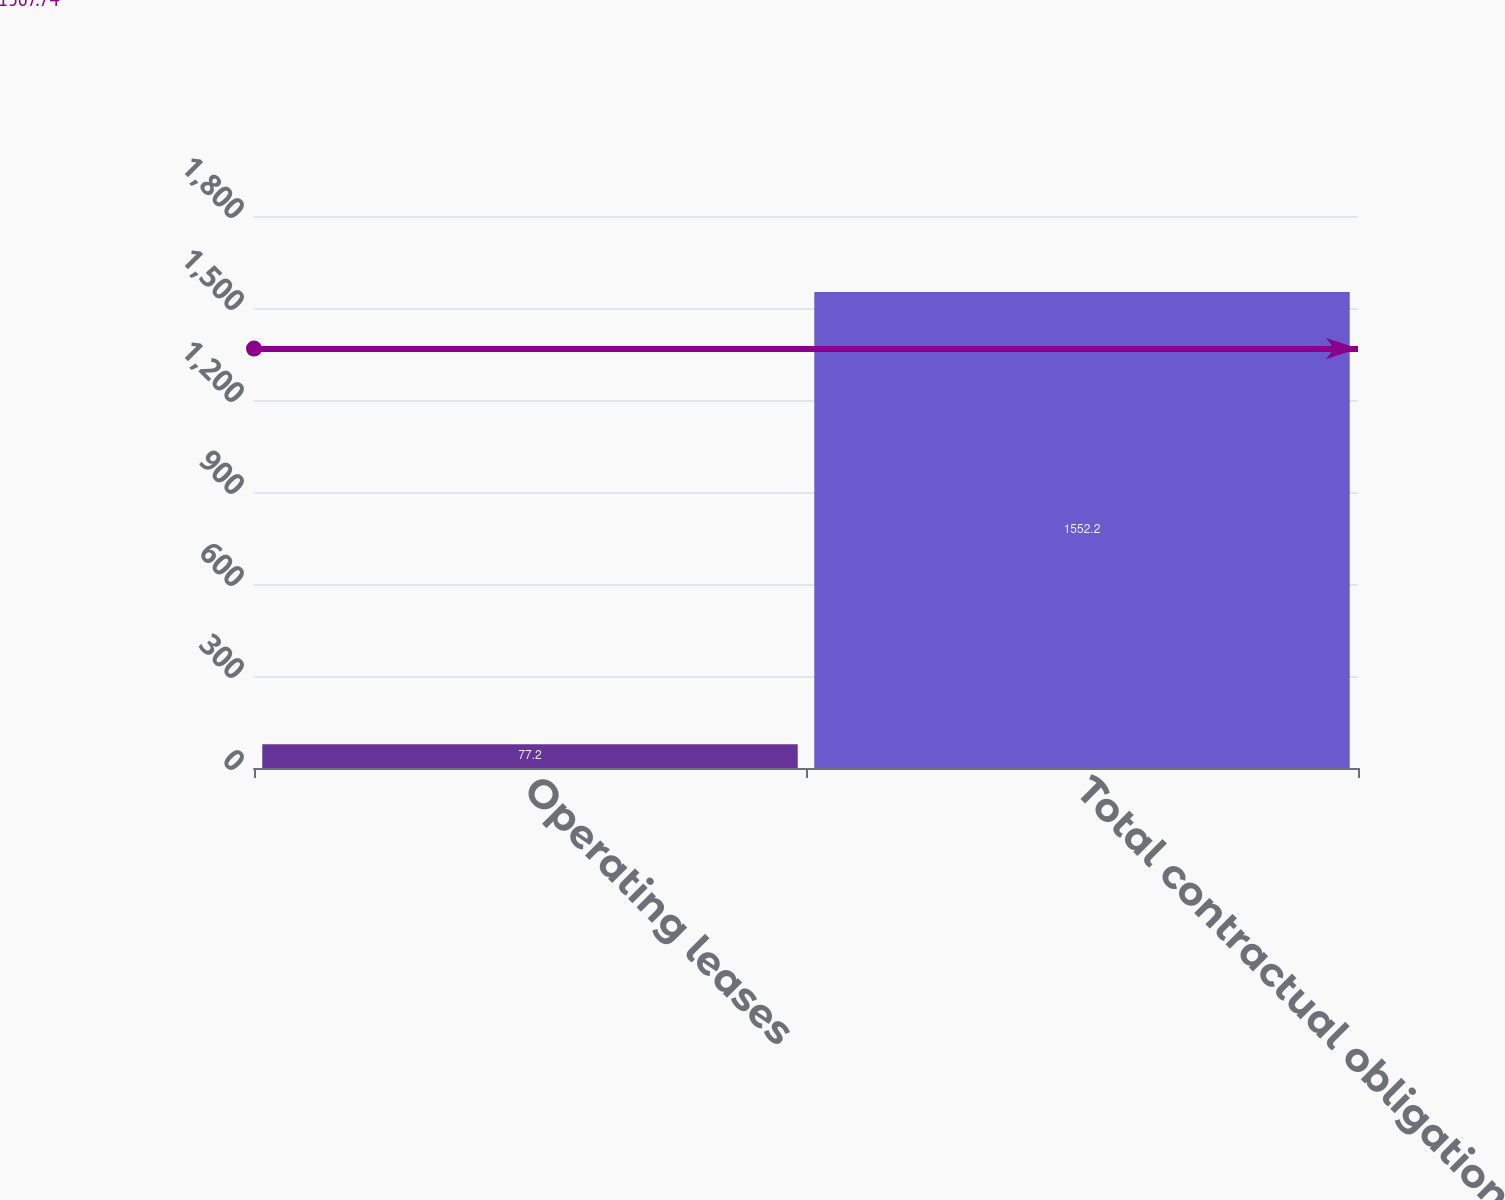Convert chart to OTSL. <chart><loc_0><loc_0><loc_500><loc_500><bar_chart><fcel>Operating leases<fcel>Total contractual obligations<nl><fcel>77.2<fcel>1552.2<nl></chart> 